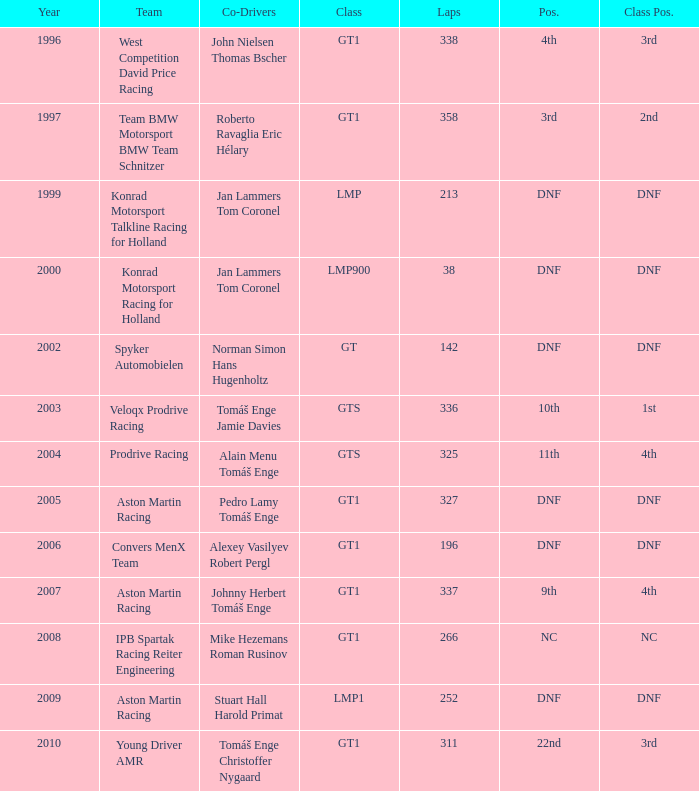Which spot concluded 3rd in the course and finished under 338 laps? 22nd. 